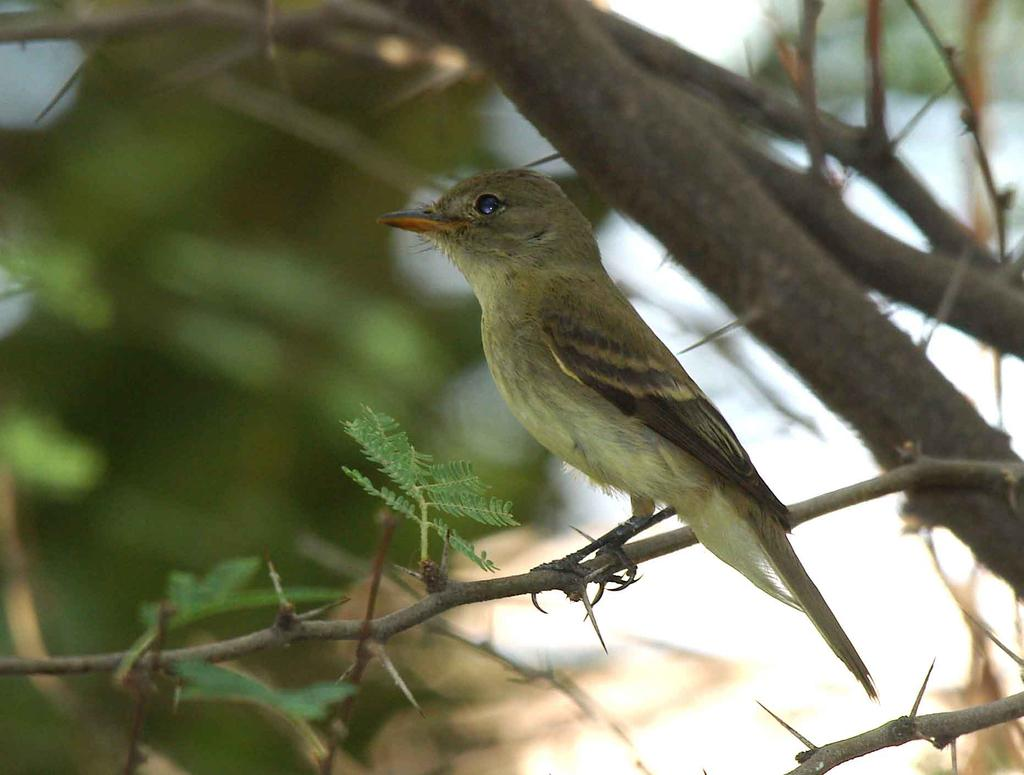What type of animal can be seen in the image? There is a bird in the image. Where is the bird located? The bird is sitting on a branch of a tree. What can be observed about the background of the tree? The background of the tree is blurred. What type of food is the bird eating in the image? There is no food visible in the image, and the bird is not shown eating anything. 